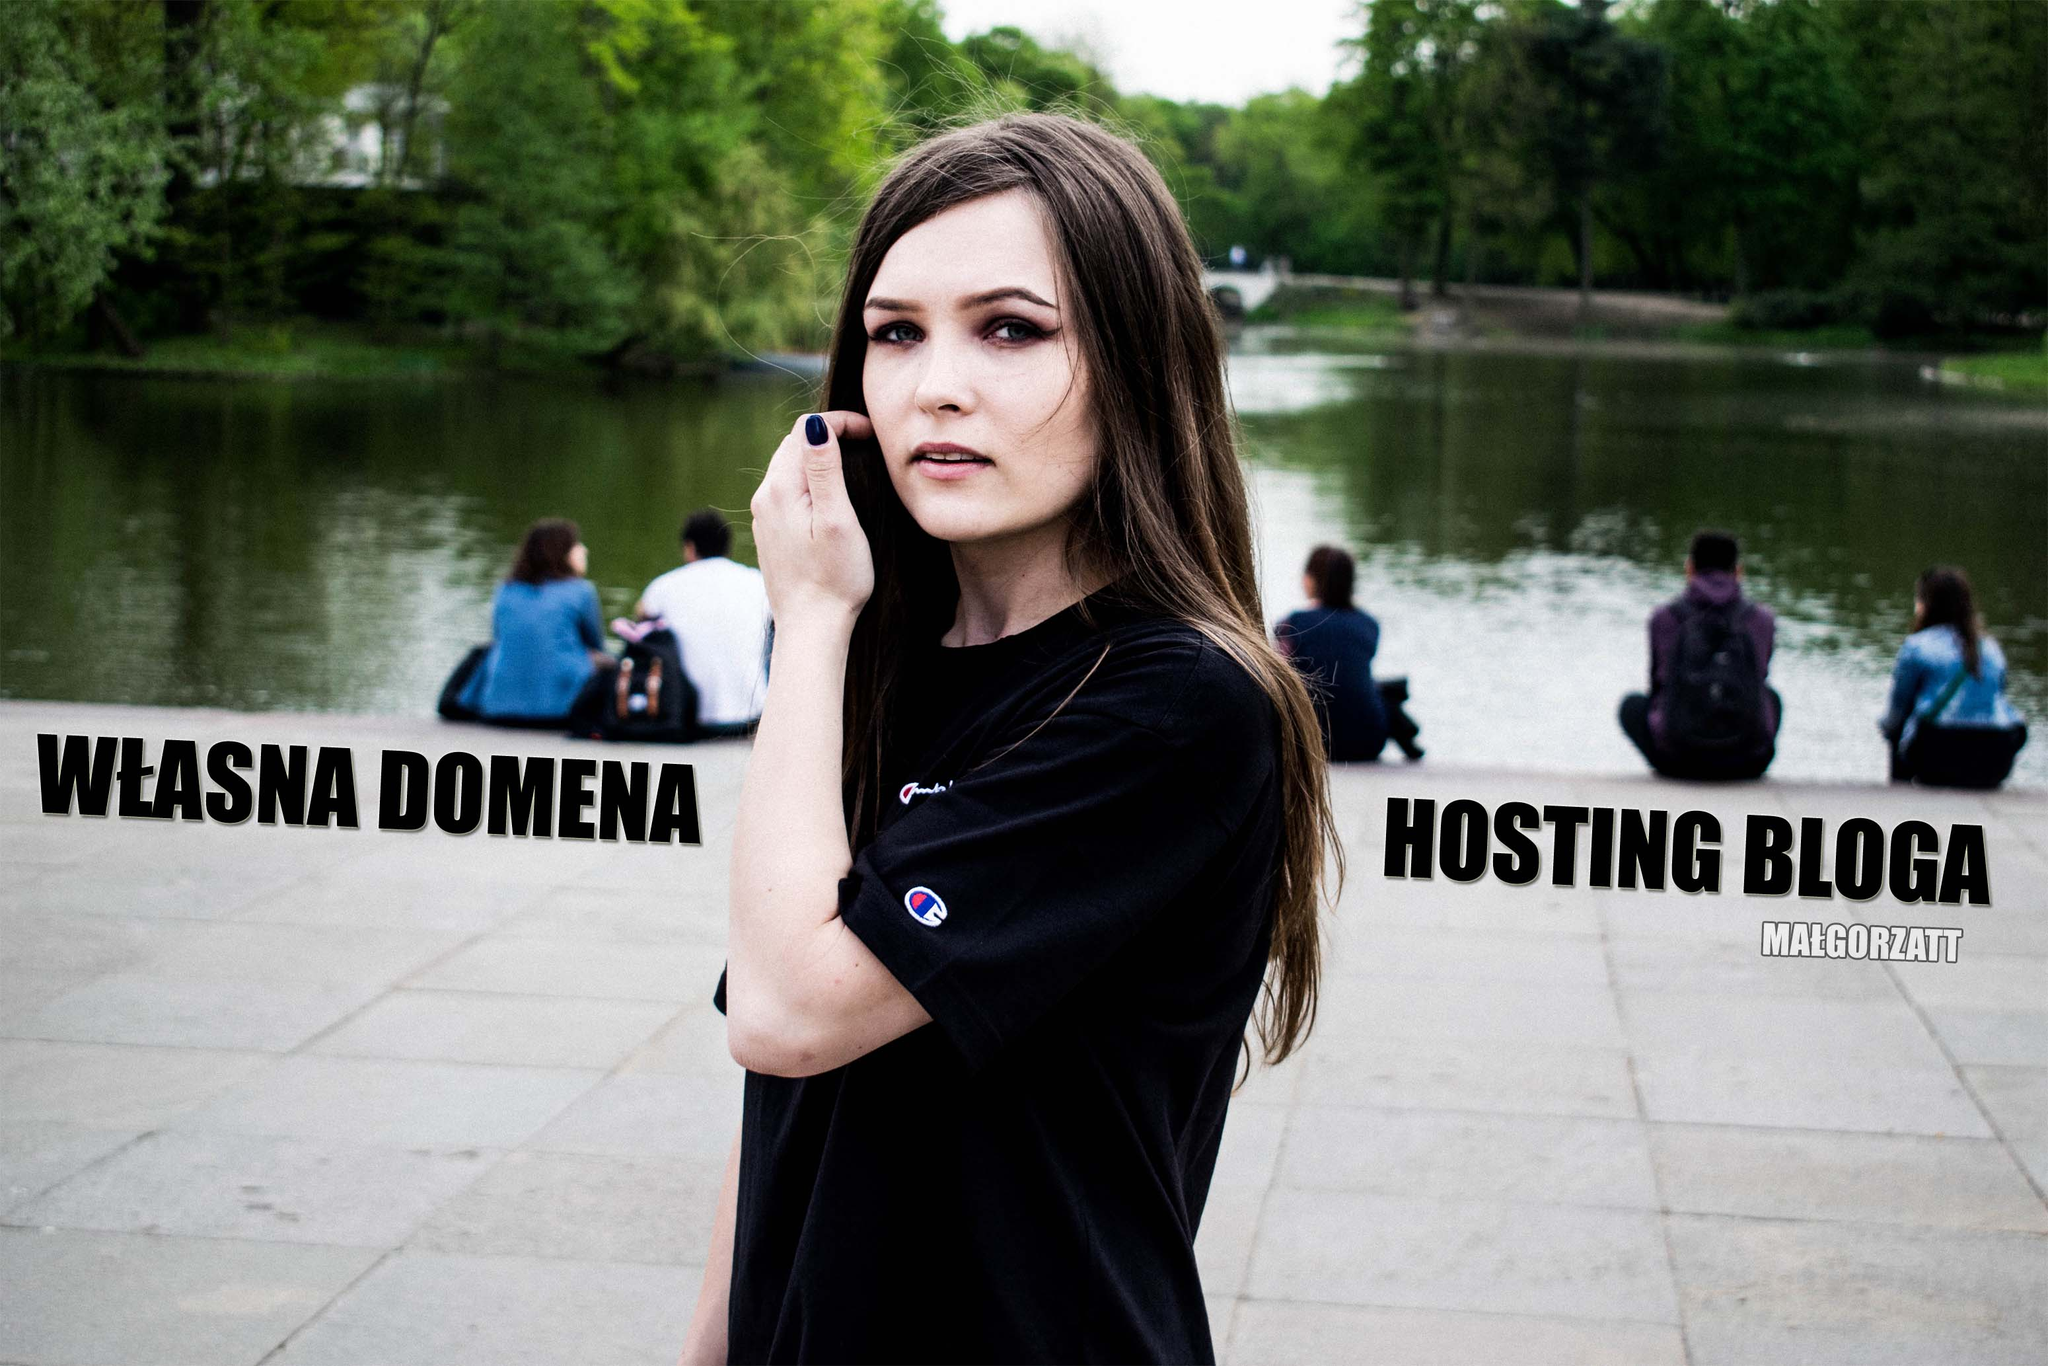Describe a realistic scenario where the woman is part of a web hosting promotional campaign. In a realistic scenario, the woman could be a brand ambassador for a web hosting company. The image is part of a series of promotional materials being used in digital marketing campaigns. She's depicted in relatable, everyday environments to connect with the target audience—bloggers, small business owners, and creatives. Alongside blog articles, social media posts, and video content, she showcases the benefits of owning a domain and blogging. Her real-life experiences and success stories serve as testimonials, enhancing the authenticity and appeal of the campaign. 